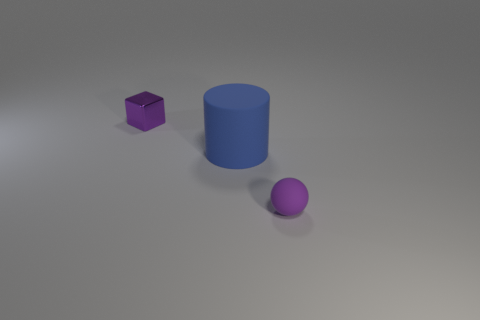What can you infer about the texture of the surface? The surface appears to have a slight texture, evident from the subtle variances in light and shadow across its expanse. It's not highly reflective, implying it has a matte or satin finish rather than glossy. 